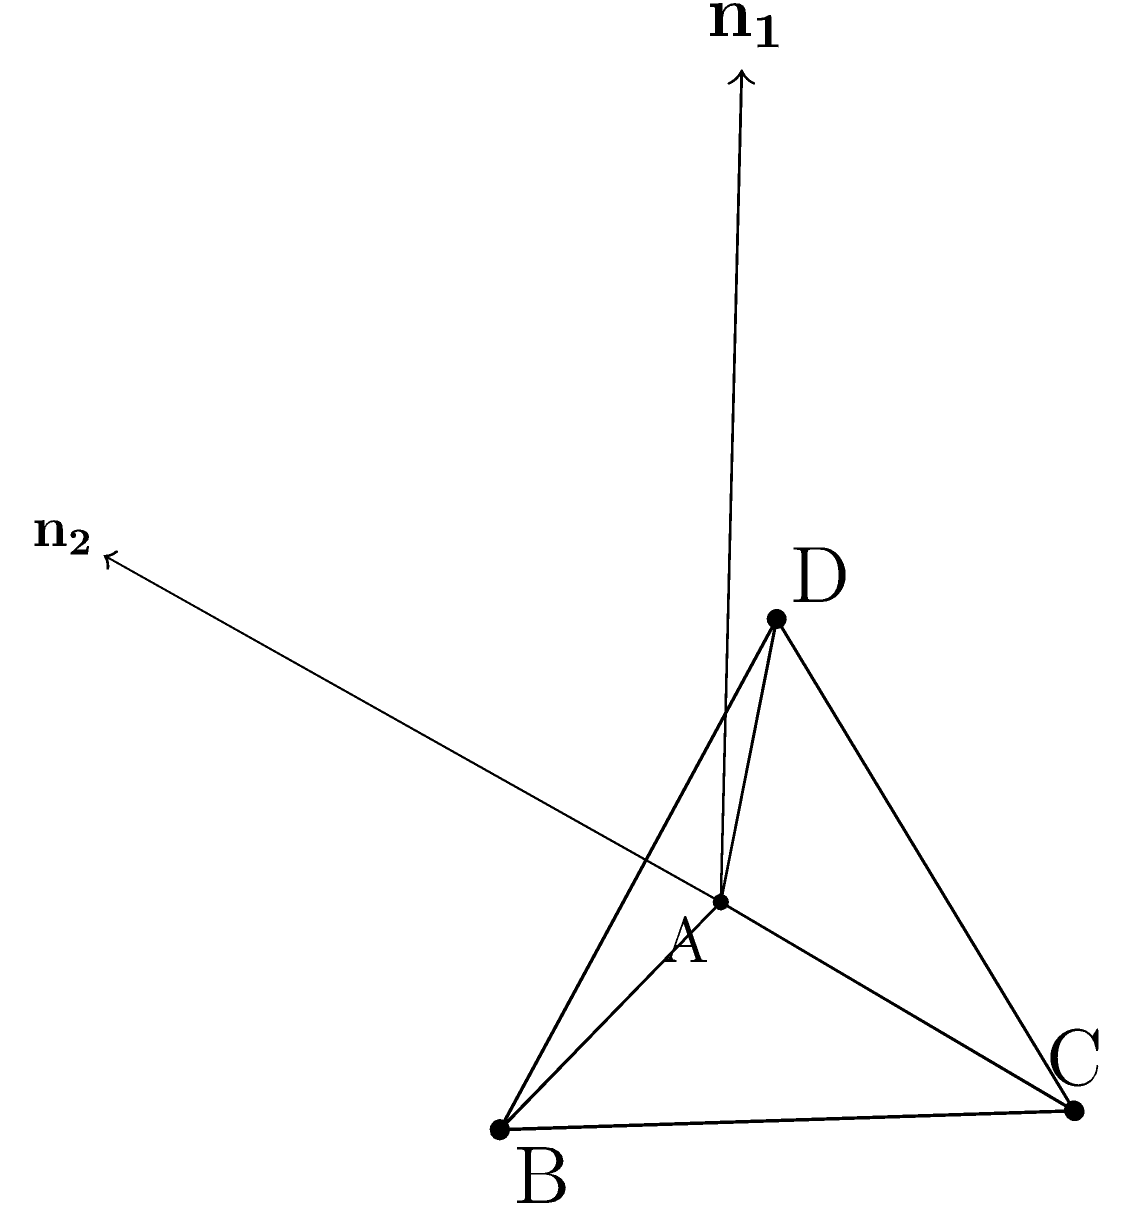In the tetrahedron ABCD shown above, planes ABC and ABD intersect along edge AB. Given that the coordinates of the vertices are A(0,0,0), B(2,0,0), C(1,1.732,0), and D(1,0.577,1.633), determine the angle between these two planes. To find the angle between two intersecting planes, we can use the dot product of their normal vectors. Here's the step-by-step solution:

1) First, we need to find the normal vectors to both planes:

   For plane ABC: $\mathbf{n_1} = \overrightarrow{AB} \times \overrightarrow{AC}$
   For plane ABD: $\mathbf{n_2} = \overrightarrow{AB} \times \overrightarrow{AD}$

2) Calculate $\overrightarrow{AB}$, $\overrightarrow{AC}$, and $\overrightarrow{AD}$:
   
   $\overrightarrow{AB} = (2,0,0) - (0,0,0) = (2,0,0)$
   $\overrightarrow{AC} = (1,1.732,0) - (0,0,0) = (1,1.732,0)$
   $\overrightarrow{AD} = (1,0.577,1.633) - (0,0,0) = (1,0.577,1.633)$

3) Calculate $\mathbf{n_1}$:
   
   $\mathbf{n_1} = (2,0,0) \times (1,1.732,0) = (0,0,3.464)$

4) Calculate $\mathbf{n_2}$:
   
   $\mathbf{n_2} = (2,0,0) \times (1,0.577,1.633) = (0,-3.266,1.154)$

5) The angle $\theta$ between the planes is given by:

   $\cos \theta = \frac{\mathbf{n_1} \cdot \mathbf{n_2}}{|\mathbf{n_1}||\mathbf{n_2}|}$

6) Calculate the dot product $\mathbf{n_1} \cdot \mathbf{n_2}$:
   
   $\mathbf{n_1} \cdot \mathbf{n_2} = (0)(0) + (0)(-3.266) + (3.464)(1.154) = 3.998$

7) Calculate the magnitudes:
   
   $|\mathbf{n_1}| = \sqrt{0^2 + 0^2 + 3.464^2} = 3.464$
   $|\mathbf{n_2}| = \sqrt{0^2 + (-3.266)^2 + 1.154^2} = 3.464$

8) Substitute into the formula:

   $\cos \theta = \frac{3.998}{(3.464)(3.464)} = 0.333$

9) Take the inverse cosine to find $\theta$:

   $\theta = \arccos(0.333) = 70.53°$
Answer: $70.53°$ 